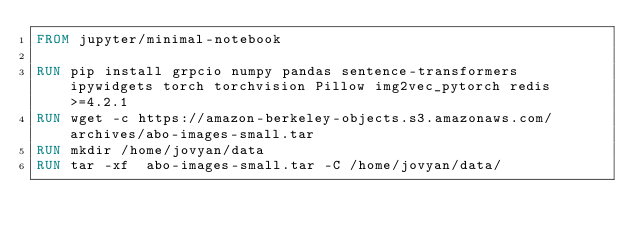<code> <loc_0><loc_0><loc_500><loc_500><_Dockerfile_>FROM jupyter/minimal-notebook

RUN pip install grpcio numpy pandas sentence-transformers ipywidgets torch torchvision Pillow img2vec_pytorch redis>=4.2.1
RUN wget -c https://amazon-berkeley-objects.s3.amazonaws.com/archives/abo-images-small.tar
RUN mkdir /home/jovyan/data
RUN tar -xf  abo-images-small.tar -C /home/jovyan/data/
</code> 